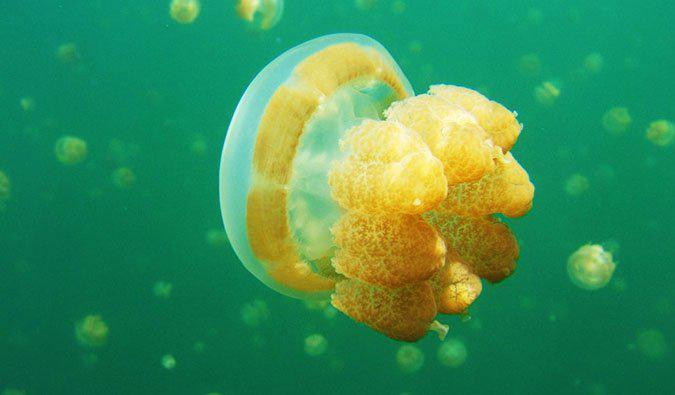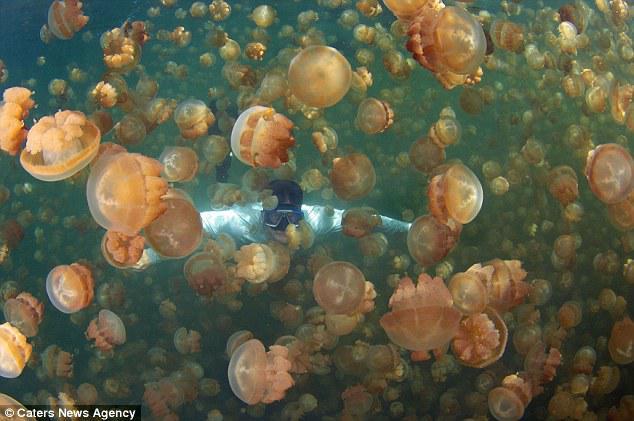The first image is the image on the left, the second image is the image on the right. Given the left and right images, does the statement "At least one of the people swimming is at least partially silhouetted against the sky." hold true? Answer yes or no. No. The first image is the image on the left, the second image is the image on the right. Considering the images on both sides, is "There are two divers with the jellyfish." valid? Answer yes or no. No. 